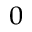<formula> <loc_0><loc_0><loc_500><loc_500>_ { 0 }</formula> 